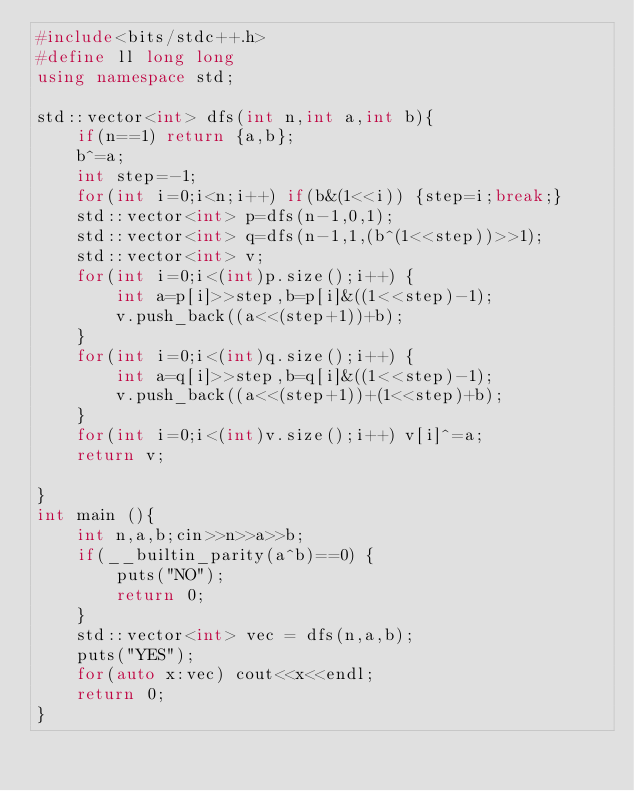Convert code to text. <code><loc_0><loc_0><loc_500><loc_500><_C++_>#include<bits/stdc++.h>
#define ll long long 
using namespace std;

std::vector<int> dfs(int n,int a,int b){
    if(n==1) return {a,b};
    b^=a;
    int step=-1;
    for(int i=0;i<n;i++) if(b&(1<<i)) {step=i;break;}
    std::vector<int> p=dfs(n-1,0,1);
    std::vector<int> q=dfs(n-1,1,(b^(1<<step))>>1);
    std::vector<int> v;
    for(int i=0;i<(int)p.size();i++) {
        int a=p[i]>>step,b=p[i]&((1<<step)-1);
        v.push_back((a<<(step+1))+b);
    }
    for(int i=0;i<(int)q.size();i++) {
        int a=q[i]>>step,b=q[i]&((1<<step)-1);
        v.push_back((a<<(step+1))+(1<<step)+b);
    }
    for(int i=0;i<(int)v.size();i++) v[i]^=a;
    return v;

}
int main (){
    int n,a,b;cin>>n>>a>>b;
    if(__builtin_parity(a^b)==0) {
        puts("NO");
        return 0;
    }
    std::vector<int> vec = dfs(n,a,b);
    puts("YES");
    for(auto x:vec) cout<<x<<endl;
    return 0;
}


</code> 